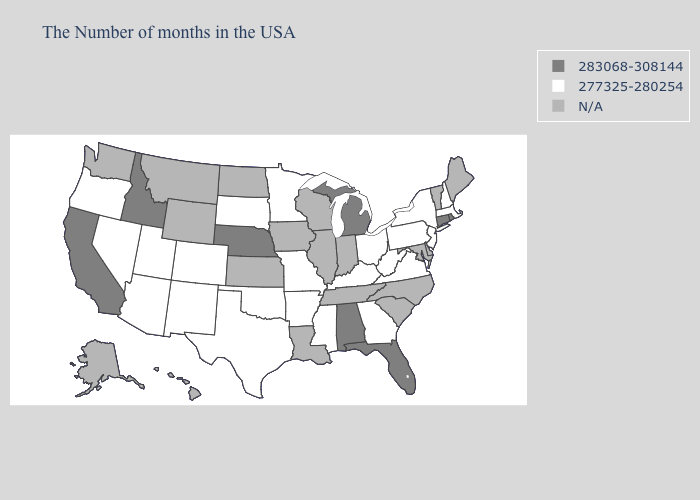How many symbols are there in the legend?
Answer briefly. 3. Does Oklahoma have the lowest value in the South?
Write a very short answer. Yes. Does the map have missing data?
Keep it brief. Yes. What is the value of Ohio?
Answer briefly. 277325-280254. What is the value of Washington?
Keep it brief. N/A. Does the first symbol in the legend represent the smallest category?
Concise answer only. No. Which states have the highest value in the USA?
Keep it brief. Rhode Island, Connecticut, Florida, Michigan, Alabama, Nebraska, Idaho, California. Name the states that have a value in the range 283068-308144?
Concise answer only. Rhode Island, Connecticut, Florida, Michigan, Alabama, Nebraska, Idaho, California. Name the states that have a value in the range 283068-308144?
Answer briefly. Rhode Island, Connecticut, Florida, Michigan, Alabama, Nebraska, Idaho, California. Does the map have missing data?
Keep it brief. Yes. What is the lowest value in the West?
Concise answer only. 277325-280254. 